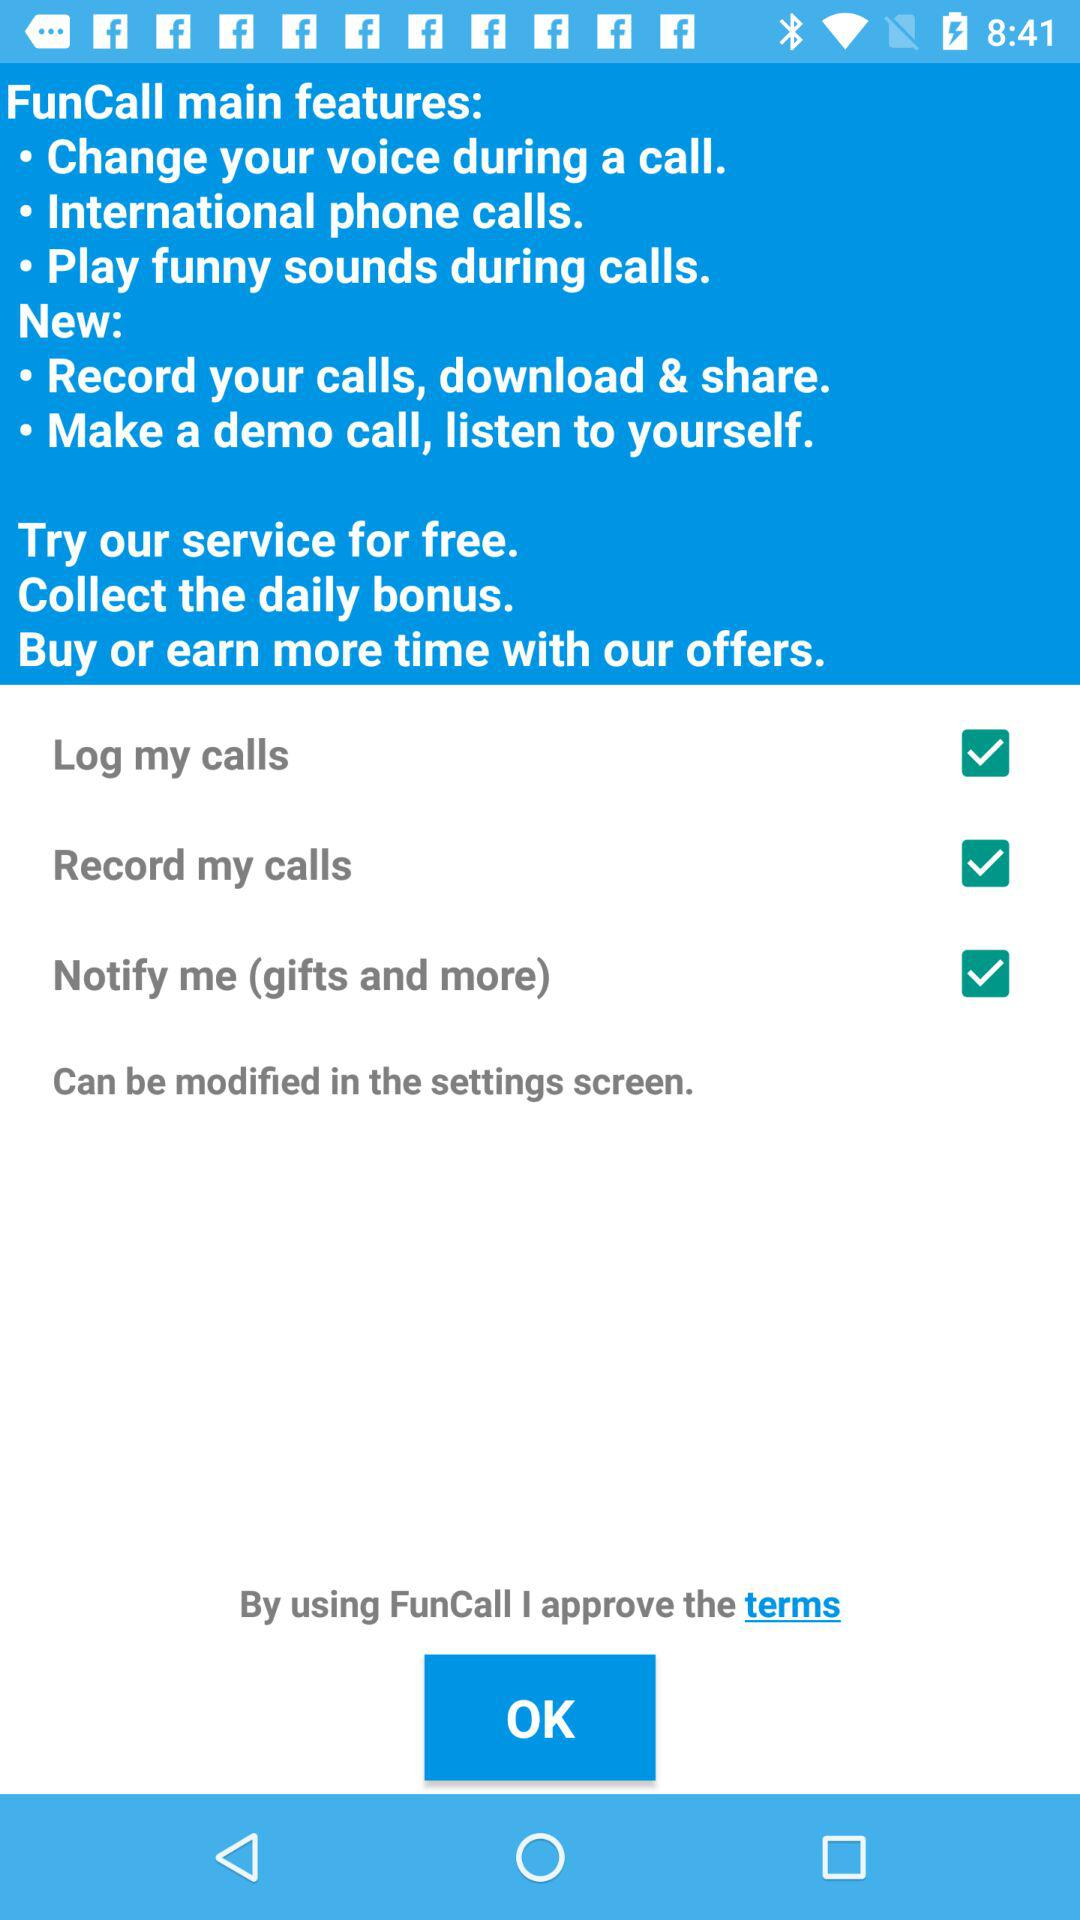What is the status of "Log my calls"? The status of "Log my calls" is "on". 